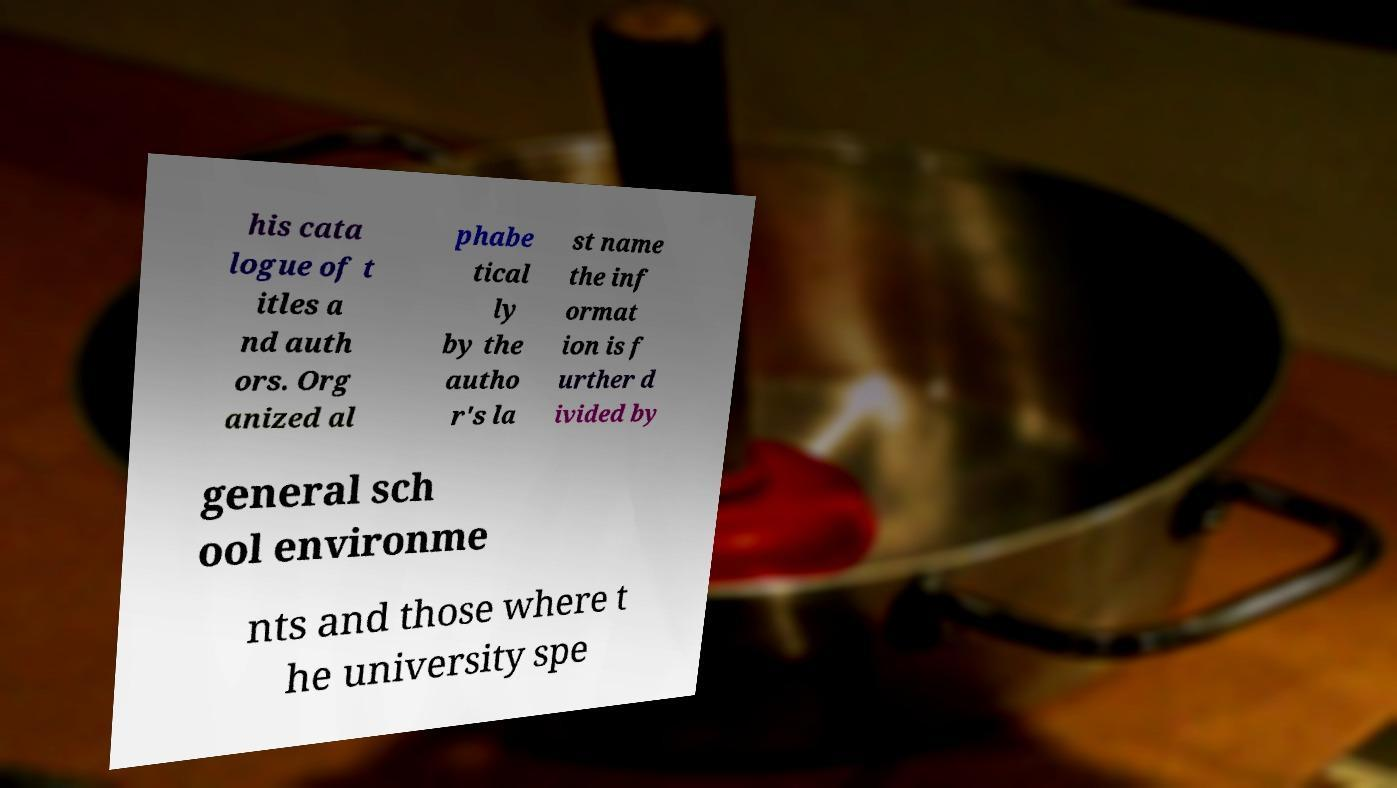Can you read and provide the text displayed in the image?This photo seems to have some interesting text. Can you extract and type it out for me? his cata logue of t itles a nd auth ors. Org anized al phabe tical ly by the autho r's la st name the inf ormat ion is f urther d ivided by general sch ool environme nts and those where t he university spe 